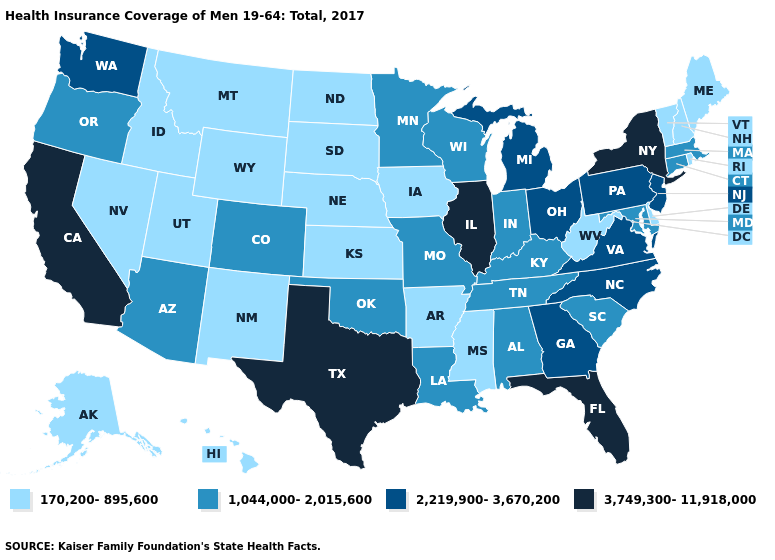Does Ohio have the same value as North Carolina?
Be succinct. Yes. What is the lowest value in states that border North Dakota?
Give a very brief answer. 170,200-895,600. What is the highest value in the MidWest ?
Be succinct. 3,749,300-11,918,000. Name the states that have a value in the range 3,749,300-11,918,000?
Give a very brief answer. California, Florida, Illinois, New York, Texas. Does Texas have the same value as Florida?
Give a very brief answer. Yes. Does the map have missing data?
Short answer required. No. What is the value of Wyoming?
Write a very short answer. 170,200-895,600. Does Connecticut have the same value as Tennessee?
Concise answer only. Yes. What is the value of Idaho?
Answer briefly. 170,200-895,600. What is the highest value in the South ?
Quick response, please. 3,749,300-11,918,000. Does the first symbol in the legend represent the smallest category?
Short answer required. Yes. What is the value of Texas?
Concise answer only. 3,749,300-11,918,000. What is the value of Minnesota?
Answer briefly. 1,044,000-2,015,600. What is the value of Georgia?
Give a very brief answer. 2,219,900-3,670,200. What is the value of Idaho?
Short answer required. 170,200-895,600. 